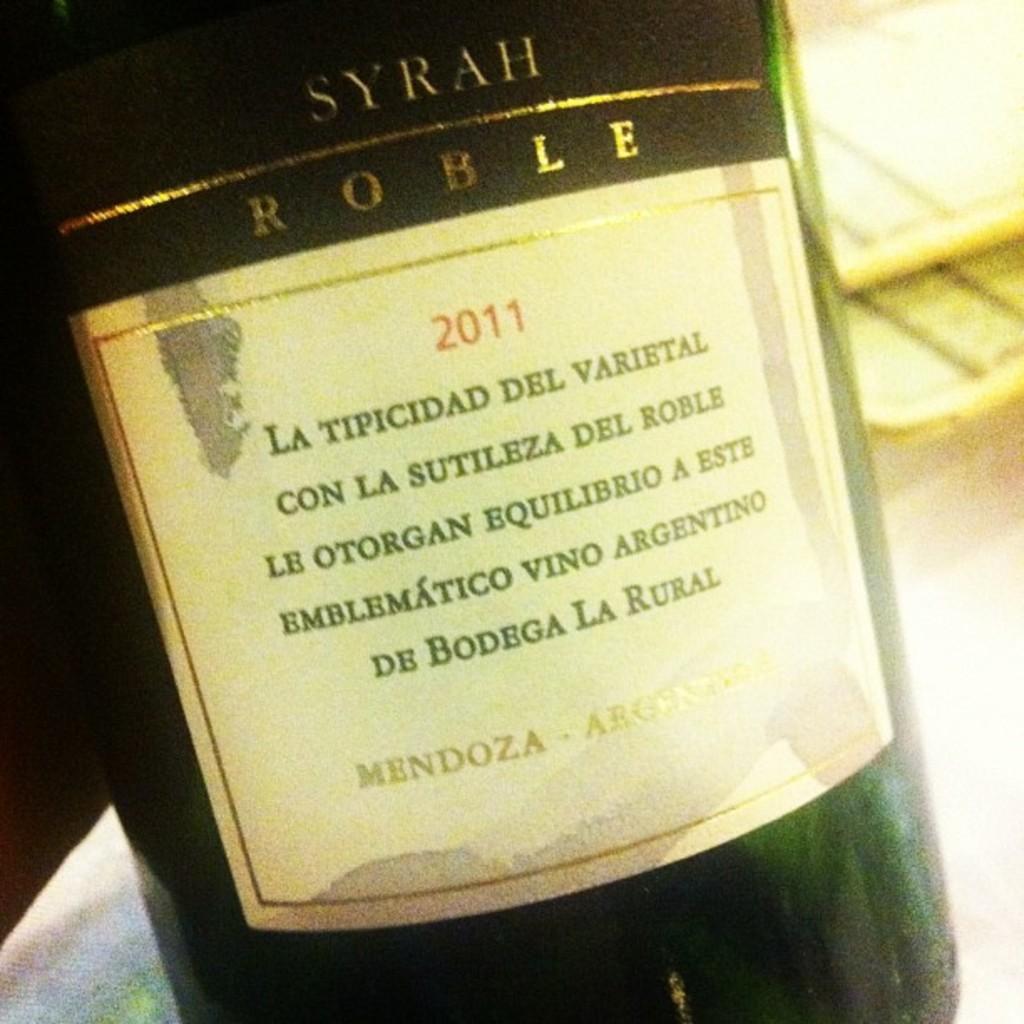What kind of wine is this?
Give a very brief answer. Syrah. 